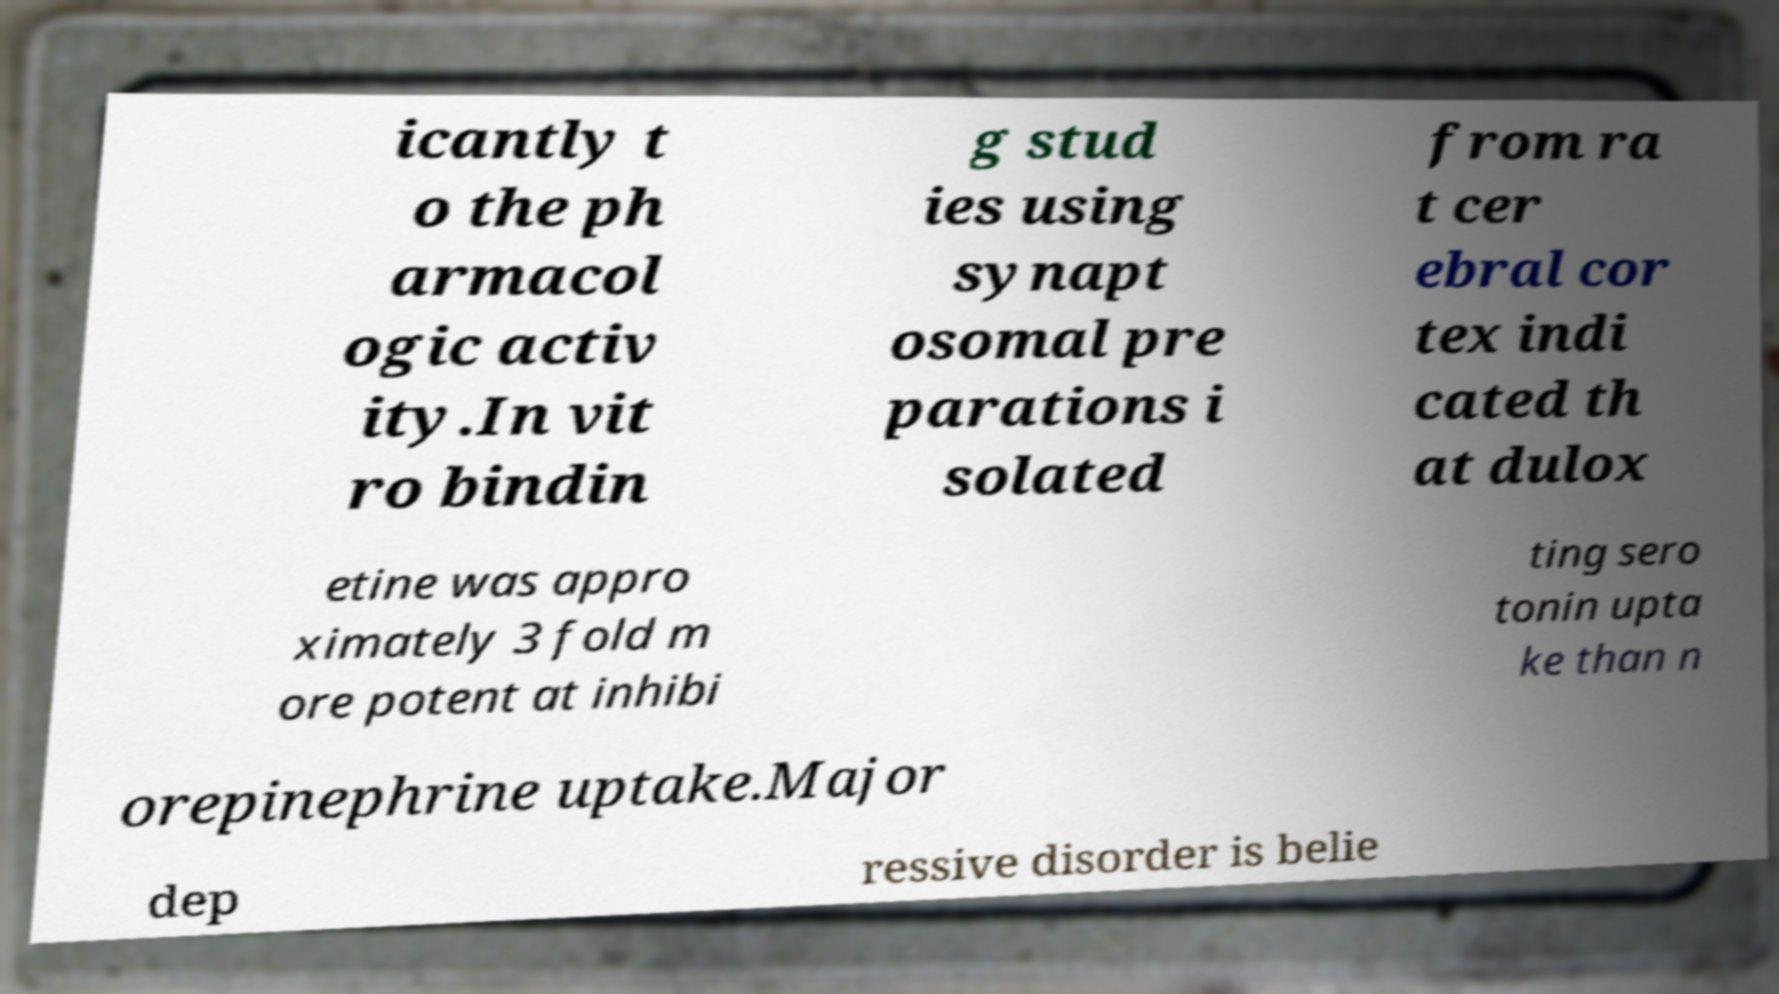There's text embedded in this image that I need extracted. Can you transcribe it verbatim? icantly t o the ph armacol ogic activ ity.In vit ro bindin g stud ies using synapt osomal pre parations i solated from ra t cer ebral cor tex indi cated th at dulox etine was appro ximately 3 fold m ore potent at inhibi ting sero tonin upta ke than n orepinephrine uptake.Major dep ressive disorder is belie 